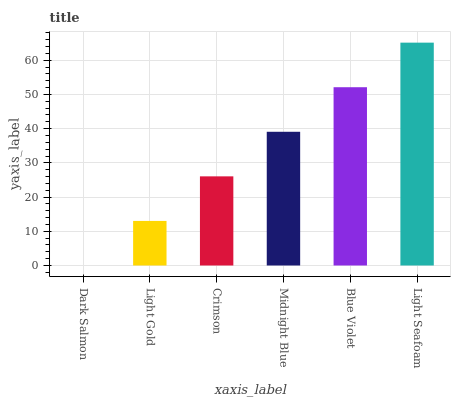Is Light Gold the minimum?
Answer yes or no. No. Is Light Gold the maximum?
Answer yes or no. No. Is Light Gold greater than Dark Salmon?
Answer yes or no. Yes. Is Dark Salmon less than Light Gold?
Answer yes or no. Yes. Is Dark Salmon greater than Light Gold?
Answer yes or no. No. Is Light Gold less than Dark Salmon?
Answer yes or no. No. Is Midnight Blue the high median?
Answer yes or no. Yes. Is Crimson the low median?
Answer yes or no. Yes. Is Dark Salmon the high median?
Answer yes or no. No. Is Dark Salmon the low median?
Answer yes or no. No. 